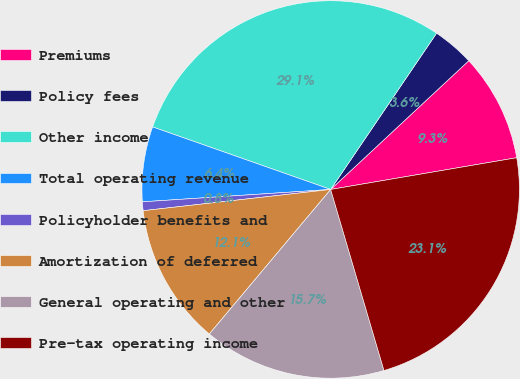Convert chart. <chart><loc_0><loc_0><loc_500><loc_500><pie_chart><fcel>Premiums<fcel>Policy fees<fcel>Other income<fcel>Total operating revenue<fcel>Policyholder benefits and<fcel>Amortization of deferred<fcel>General operating and other<fcel>Pre-tax operating income<nl><fcel>9.25%<fcel>3.58%<fcel>29.1%<fcel>6.42%<fcel>0.75%<fcel>12.09%<fcel>15.67%<fcel>23.13%<nl></chart> 